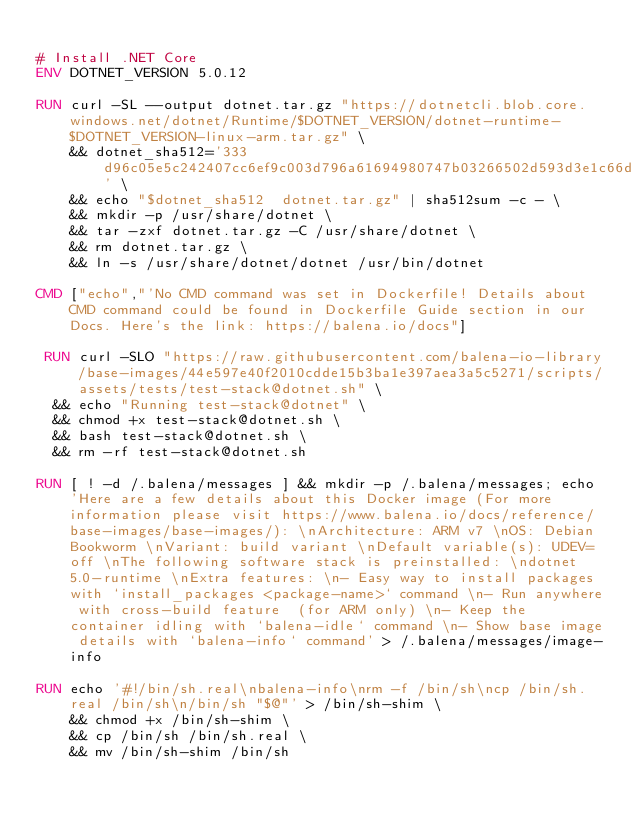Convert code to text. <code><loc_0><loc_0><loc_500><loc_500><_Dockerfile_>
# Install .NET Core
ENV DOTNET_VERSION 5.0.12

RUN curl -SL --output dotnet.tar.gz "https://dotnetcli.blob.core.windows.net/dotnet/Runtime/$DOTNET_VERSION/dotnet-runtime-$DOTNET_VERSION-linux-arm.tar.gz" \
    && dotnet_sha512='333d96c05e5c242407cc6ef9c003d796a61694980747b03266502d593d3e1c66d5e6147bfb41796df76ff0144617ee33c56afba740dd3eb4ea090a742b1c73d4' \
    && echo "$dotnet_sha512  dotnet.tar.gz" | sha512sum -c - \
    && mkdir -p /usr/share/dotnet \
    && tar -zxf dotnet.tar.gz -C /usr/share/dotnet \
    && rm dotnet.tar.gz \
    && ln -s /usr/share/dotnet/dotnet /usr/bin/dotnet

CMD ["echo","'No CMD command was set in Dockerfile! Details about CMD command could be found in Dockerfile Guide section in our Docs. Here's the link: https://balena.io/docs"]

 RUN curl -SLO "https://raw.githubusercontent.com/balena-io-library/base-images/44e597e40f2010cdde15b3ba1e397aea3a5c5271/scripts/assets/tests/test-stack@dotnet.sh" \
  && echo "Running test-stack@dotnet" \
  && chmod +x test-stack@dotnet.sh \
  && bash test-stack@dotnet.sh \
  && rm -rf test-stack@dotnet.sh 

RUN [ ! -d /.balena/messages ] && mkdir -p /.balena/messages; echo 'Here are a few details about this Docker image (For more information please visit https://www.balena.io/docs/reference/base-images/base-images/): \nArchitecture: ARM v7 \nOS: Debian Bookworm \nVariant: build variant \nDefault variable(s): UDEV=off \nThe following software stack is preinstalled: \ndotnet 5.0-runtime \nExtra features: \n- Easy way to install packages with `install_packages <package-name>` command \n- Run anywhere with cross-build feature  (for ARM only) \n- Keep the container idling with `balena-idle` command \n- Show base image details with `balena-info` command' > /.balena/messages/image-info

RUN echo '#!/bin/sh.real\nbalena-info\nrm -f /bin/sh\ncp /bin/sh.real /bin/sh\n/bin/sh "$@"' > /bin/sh-shim \
	&& chmod +x /bin/sh-shim \
	&& cp /bin/sh /bin/sh.real \
	&& mv /bin/sh-shim /bin/sh</code> 